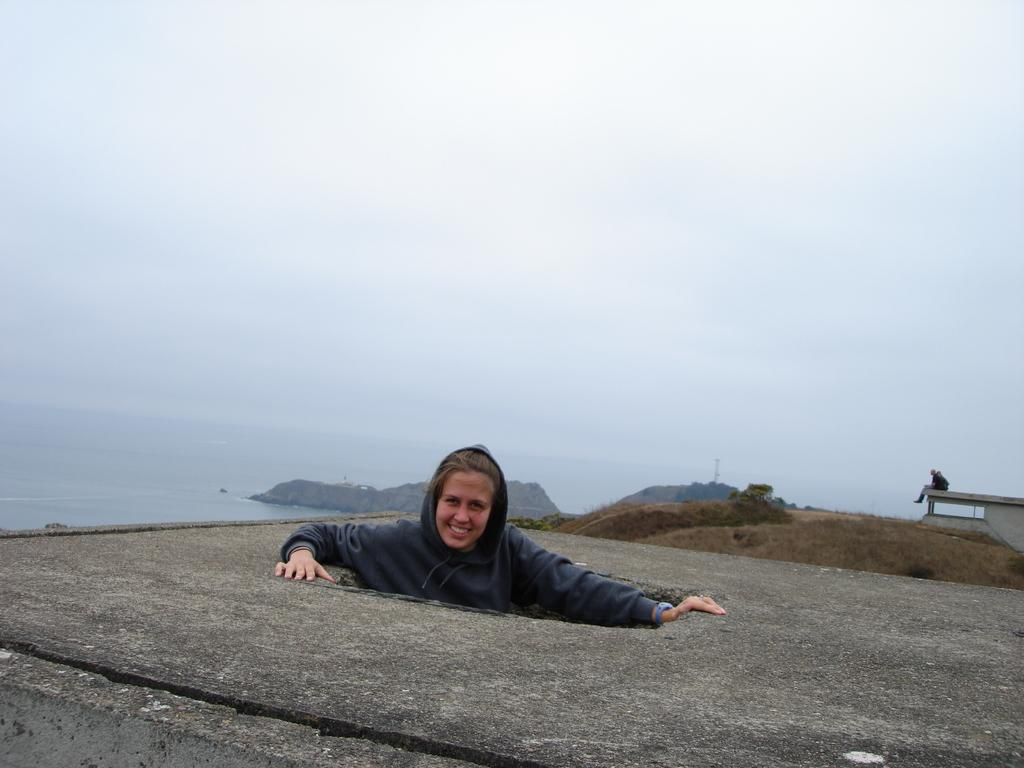What is the person in the image wearing? There is a person wearing a hoodie in the image. What is the person sitting on in the image? The person is sitting on an object on the right side of the image. What can be seen in the background of the image? There is water visible in the image, and there are clouds in the sky. Can you tell me the value of the owl in the image? There is no owl present in the image, so it is not possible to determine its value. 